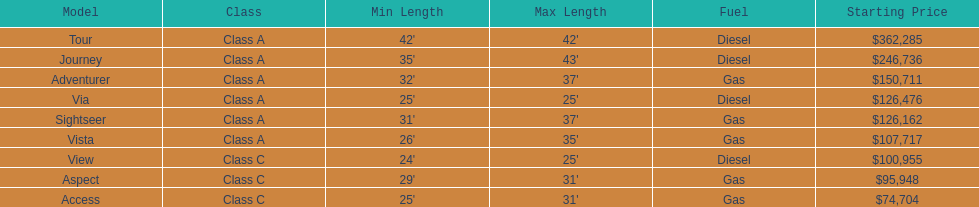What is the total number of class a models? 6. 